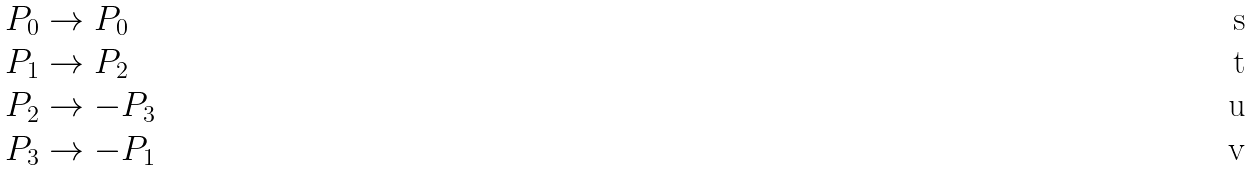<formula> <loc_0><loc_0><loc_500><loc_500>P _ { 0 } & \to P _ { 0 } \\ P _ { 1 } & \to P _ { 2 } \\ P _ { 2 } & \to - P _ { 3 } \\ P _ { 3 } & \to - P _ { 1 }</formula> 